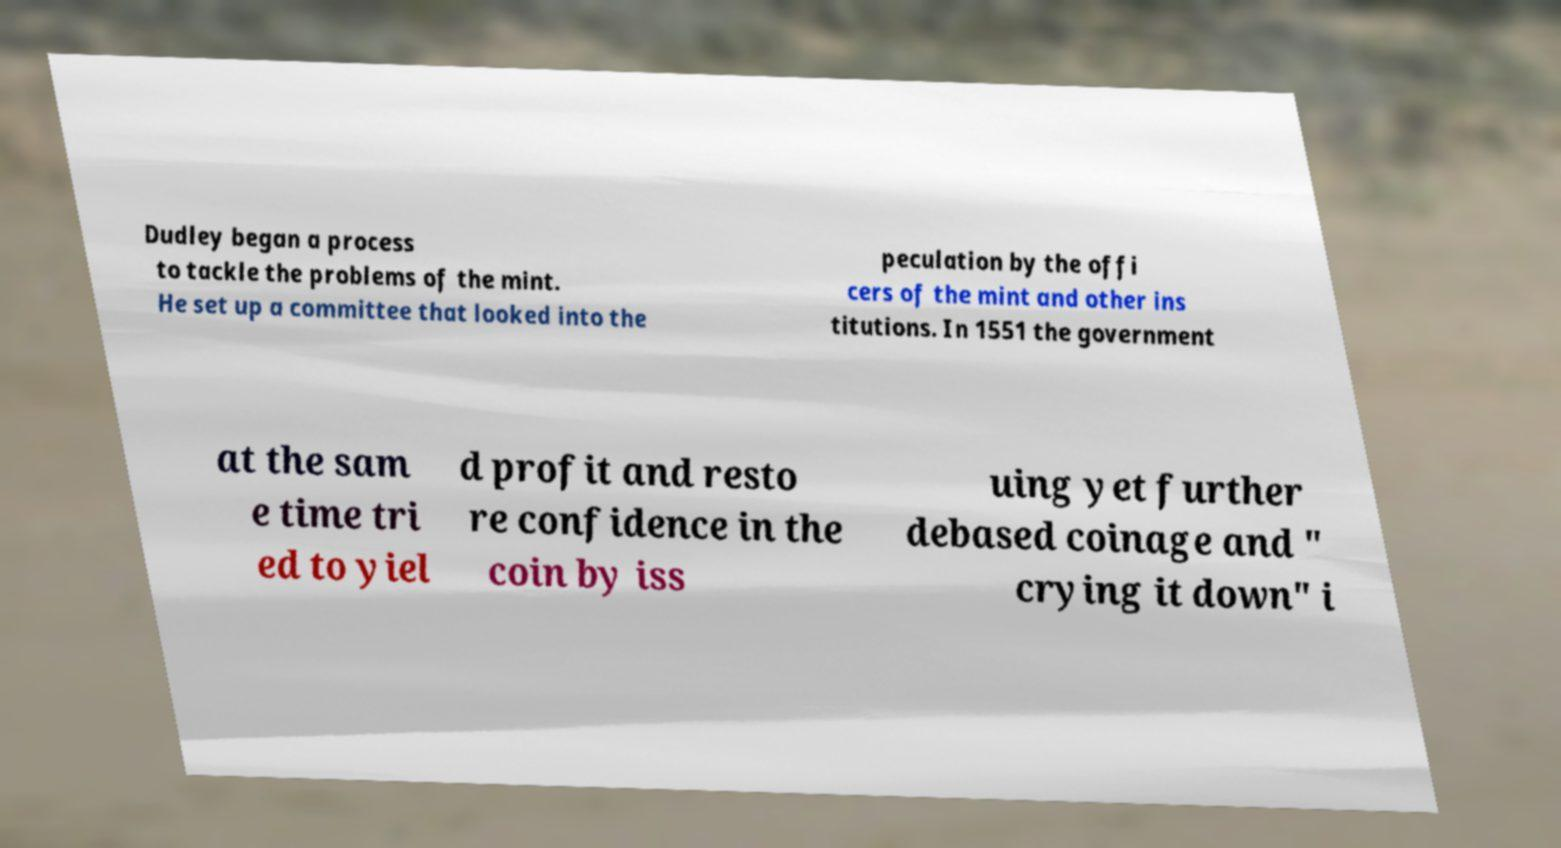Could you assist in decoding the text presented in this image and type it out clearly? Dudley began a process to tackle the problems of the mint. He set up a committee that looked into the peculation by the offi cers of the mint and other ins titutions. In 1551 the government at the sam e time tri ed to yiel d profit and resto re confidence in the coin by iss uing yet further debased coinage and " crying it down" i 